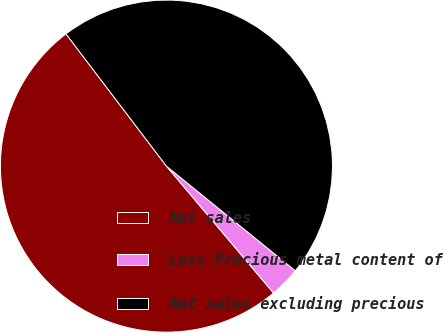Convert chart to OTSL. <chart><loc_0><loc_0><loc_500><loc_500><pie_chart><fcel>Net sales<fcel>Less Precious metal content of<fcel>Net sales excluding precious<nl><fcel>50.82%<fcel>2.99%<fcel>46.2%<nl></chart> 